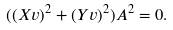Convert formula to latex. <formula><loc_0><loc_0><loc_500><loc_500>( ( X v ) ^ { 2 } + ( Y v ) ^ { 2 } ) A ^ { 2 } = 0 .</formula> 